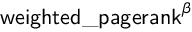<formula> <loc_0><loc_0><loc_500><loc_500>w e i g h t e d \_ p a g e r a n k ^ { \beta }</formula> 